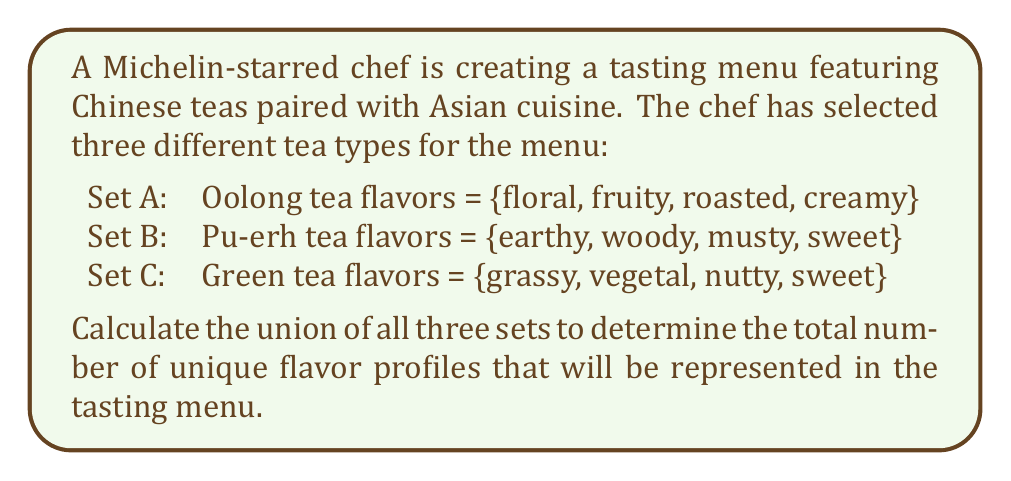Show me your answer to this math problem. To solve this problem, we need to find the union of sets A, B, and C. The union of these sets will include all unique elements from all three sets, without duplicates.

Let's follow these steps:

1. List all elements from all sets:
   A ∪ B ∪ C = {floral, fruity, roasted, creamy, earthy, woody, musty, sweet, grassy, vegetal, nutty}

2. Identify and count unique elements:
   - floral (from A)
   - fruity (from A)
   - roasted (from A)
   - creamy (from A)
   - earthy (from B)
   - woody (from B)
   - musty (from B)
   - sweet (from B and C, count only once)
   - grassy (from C)
   - vegetal (from C)
   - nutty (from C)

3. Count the total number of unique elements:
   There are 11 unique flavor profiles in the union of the three sets.

We can represent this mathematically as:

$$|A ∪ B ∪ C| = 11$$

Where $|A ∪ B ∪ C|$ denotes the cardinality (number of elements) in the union of sets A, B, and C.
Answer: $$|A ∪ B ∪ C| = 11$$ 